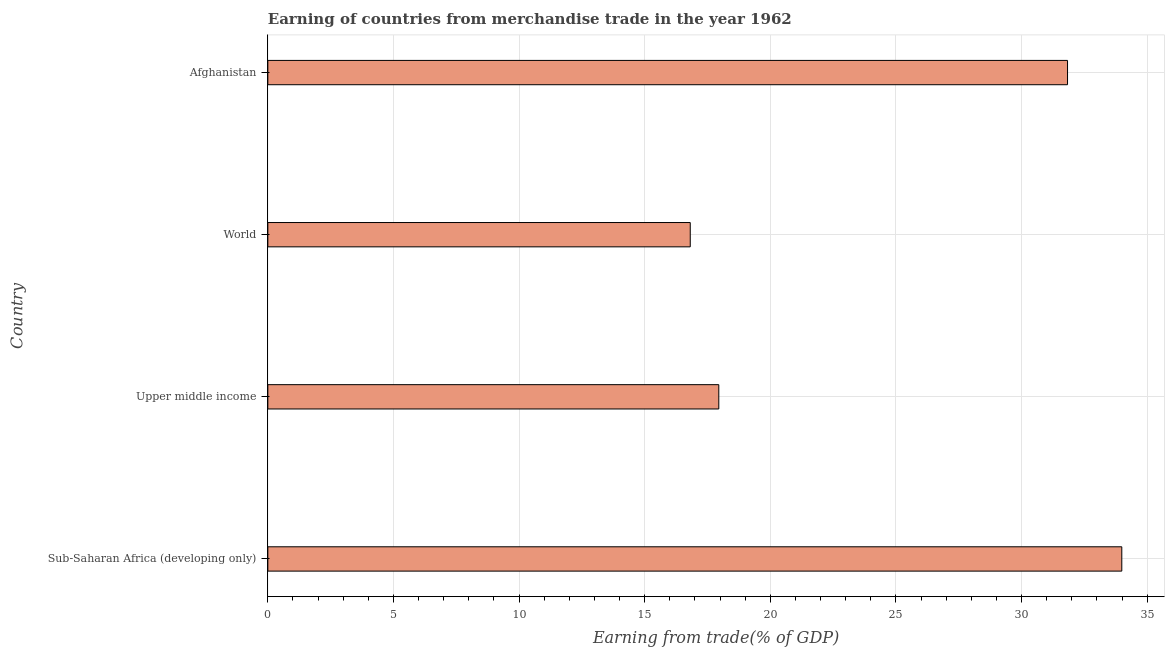Does the graph contain any zero values?
Your response must be concise. No. What is the title of the graph?
Your response must be concise. Earning of countries from merchandise trade in the year 1962. What is the label or title of the X-axis?
Your answer should be compact. Earning from trade(% of GDP). What is the label or title of the Y-axis?
Keep it short and to the point. Country. What is the earning from merchandise trade in Afghanistan?
Provide a short and direct response. 31.83. Across all countries, what is the maximum earning from merchandise trade?
Offer a very short reply. 33.99. Across all countries, what is the minimum earning from merchandise trade?
Provide a succinct answer. 16.81. In which country was the earning from merchandise trade maximum?
Ensure brevity in your answer.  Sub-Saharan Africa (developing only). In which country was the earning from merchandise trade minimum?
Provide a short and direct response. World. What is the sum of the earning from merchandise trade?
Provide a succinct answer. 100.58. What is the difference between the earning from merchandise trade in Afghanistan and Sub-Saharan Africa (developing only)?
Your answer should be very brief. -2.16. What is the average earning from merchandise trade per country?
Offer a very short reply. 25.14. What is the median earning from merchandise trade?
Keep it short and to the point. 24.89. What is the ratio of the earning from merchandise trade in Sub-Saharan Africa (developing only) to that in World?
Your answer should be very brief. 2.02. Is the earning from merchandise trade in Afghanistan less than that in Sub-Saharan Africa (developing only)?
Your answer should be compact. Yes. Is the difference between the earning from merchandise trade in Afghanistan and World greater than the difference between any two countries?
Give a very brief answer. No. What is the difference between the highest and the second highest earning from merchandise trade?
Provide a succinct answer. 2.16. What is the difference between the highest and the lowest earning from merchandise trade?
Offer a terse response. 17.18. In how many countries, is the earning from merchandise trade greater than the average earning from merchandise trade taken over all countries?
Provide a succinct answer. 2. How many bars are there?
Your answer should be compact. 4. What is the Earning from trade(% of GDP) in Sub-Saharan Africa (developing only)?
Provide a succinct answer. 33.99. What is the Earning from trade(% of GDP) of Upper middle income?
Keep it short and to the point. 17.95. What is the Earning from trade(% of GDP) in World?
Keep it short and to the point. 16.81. What is the Earning from trade(% of GDP) of Afghanistan?
Keep it short and to the point. 31.83. What is the difference between the Earning from trade(% of GDP) in Sub-Saharan Africa (developing only) and Upper middle income?
Your answer should be very brief. 16.04. What is the difference between the Earning from trade(% of GDP) in Sub-Saharan Africa (developing only) and World?
Offer a very short reply. 17.18. What is the difference between the Earning from trade(% of GDP) in Sub-Saharan Africa (developing only) and Afghanistan?
Make the answer very short. 2.16. What is the difference between the Earning from trade(% of GDP) in Upper middle income and World?
Offer a very short reply. 1.14. What is the difference between the Earning from trade(% of GDP) in Upper middle income and Afghanistan?
Give a very brief answer. -13.88. What is the difference between the Earning from trade(% of GDP) in World and Afghanistan?
Your response must be concise. -15.02. What is the ratio of the Earning from trade(% of GDP) in Sub-Saharan Africa (developing only) to that in Upper middle income?
Provide a short and direct response. 1.89. What is the ratio of the Earning from trade(% of GDP) in Sub-Saharan Africa (developing only) to that in World?
Ensure brevity in your answer.  2.02. What is the ratio of the Earning from trade(% of GDP) in Sub-Saharan Africa (developing only) to that in Afghanistan?
Your answer should be very brief. 1.07. What is the ratio of the Earning from trade(% of GDP) in Upper middle income to that in World?
Offer a very short reply. 1.07. What is the ratio of the Earning from trade(% of GDP) in Upper middle income to that in Afghanistan?
Give a very brief answer. 0.56. What is the ratio of the Earning from trade(% of GDP) in World to that in Afghanistan?
Give a very brief answer. 0.53. 